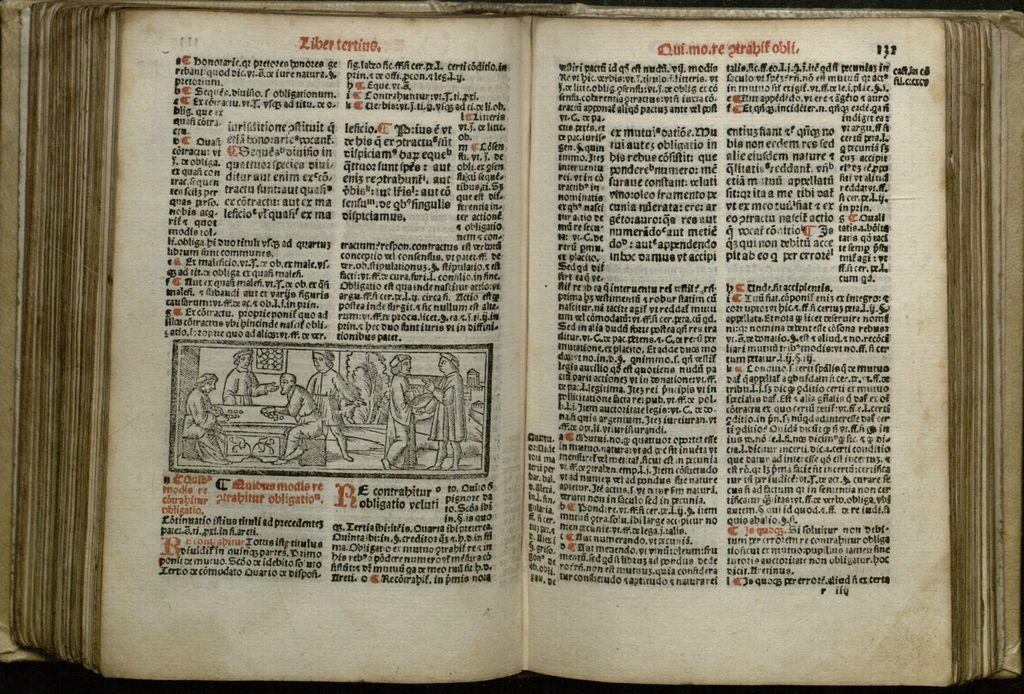Provide a one-sentence caption for the provided image. An old book written by Ziber Tertino is laying open to a page with a crude illustration and written in a foreign tongue. 